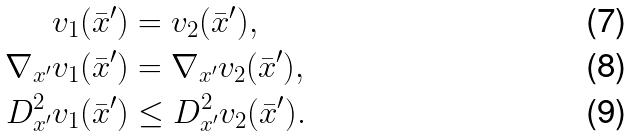<formula> <loc_0><loc_0><loc_500><loc_500>v _ { 1 } ( { \bar { x } } ^ { \prime } ) & = v _ { 2 } ( { \bar { x } } ^ { \prime } ) , \\ \nabla _ { x ^ { \prime } } v _ { 1 } ( { \bar { x } } ^ { \prime } ) & = \nabla _ { x ^ { \prime } } v _ { 2 } ( { \bar { x } } ^ { \prime } ) , \\ D ^ { 2 } _ { x ^ { \prime } } v _ { 1 } ( { \bar { x } } ^ { \prime } ) & \leq D ^ { 2 } _ { x ^ { \prime } } v _ { 2 } ( { \bar { x } } ^ { \prime } ) .</formula> 